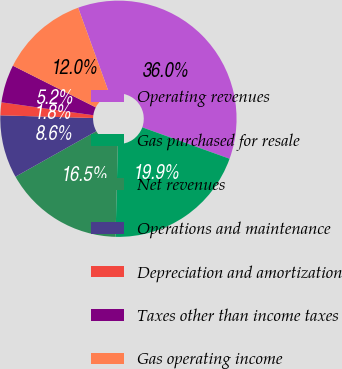Convert chart. <chart><loc_0><loc_0><loc_500><loc_500><pie_chart><fcel>Operating revenues<fcel>Gas purchased for resale<fcel>Net revenues<fcel>Operations and maintenance<fcel>Depreciation and amortization<fcel>Taxes other than income taxes<fcel>Gas operating income<nl><fcel>36.04%<fcel>19.89%<fcel>16.46%<fcel>8.62%<fcel>1.76%<fcel>5.19%<fcel>12.05%<nl></chart> 